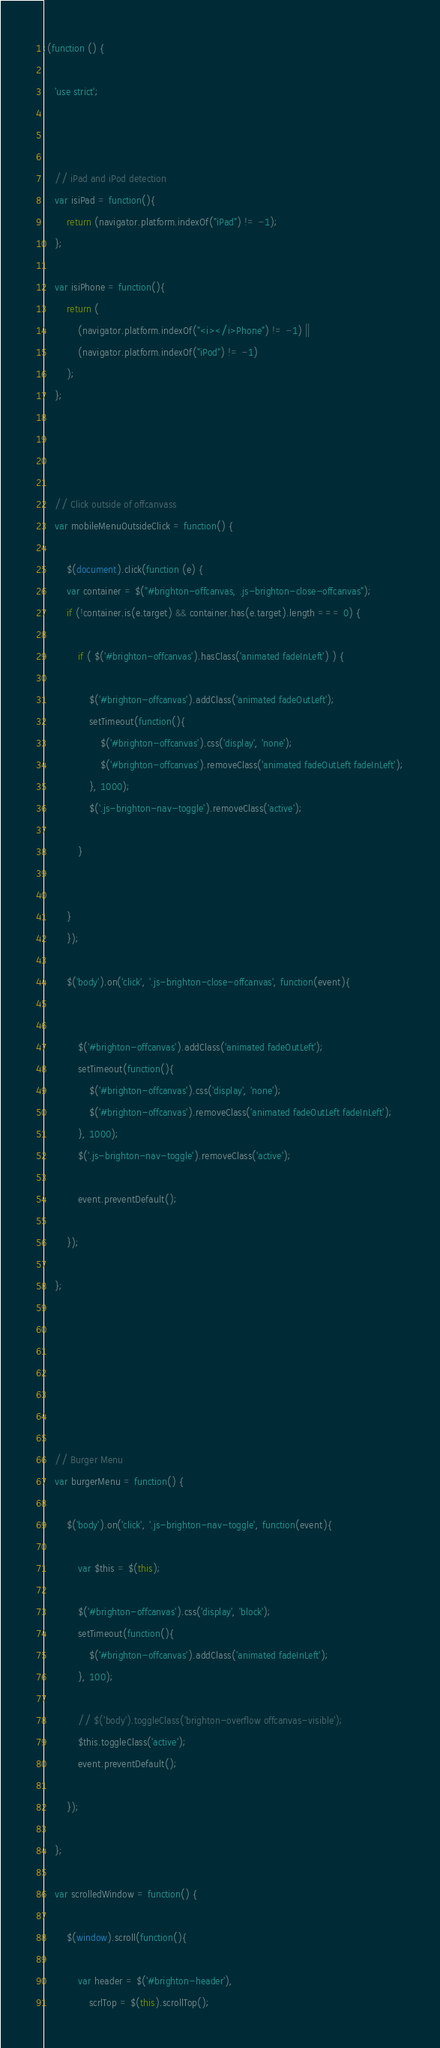<code> <loc_0><loc_0><loc_500><loc_500><_JavaScript_>;(function () {

	'use strict';



	// iPad and iPod detection
	var isiPad = function(){
		return (navigator.platform.indexOf("iPad") != -1);
	};

	var isiPhone = function(){
	    return (
			(navigator.platform.indexOf("<i></i>Phone") != -1) ||
			(navigator.platform.indexOf("iPod") != -1)
	    );
	};




	// Click outside of offcanvass
	var mobileMenuOutsideClick = function() {

		$(document).click(function (e) {
	    var container = $("#brighton-offcanvas, .js-brighton-close-offcanvas");
	    if (!container.is(e.target) && container.has(e.target).length === 0) {

	    	if ( $('#brighton-offcanvas').hasClass('animated fadeInLeft') ) {

    			$('#brighton-offcanvas').addClass('animated fadeOutLeft');
				setTimeout(function(){
					$('#brighton-offcanvas').css('display', 'none');
					$('#brighton-offcanvas').removeClass('animated fadeOutLeft fadeInLeft');
				}, 1000);
				$('.js-brighton-nav-toggle').removeClass('active');

	    	}


	    }
		});

		$('body').on('click', '.js-brighton-close-offcanvas', function(event){


	  		$('#brighton-offcanvas').addClass('animated fadeOutLeft');
			setTimeout(function(){
				$('#brighton-offcanvas').css('display', 'none');
				$('#brighton-offcanvas').removeClass('animated fadeOutLeft fadeInLeft');
			}, 1000);
			$('.js-brighton-nav-toggle').removeClass('active');

	    	event.preventDefault();

		});

	};







	// Burger Menu
	var burgerMenu = function() {

		$('body').on('click', '.js-brighton-nav-toggle', function(event){

			var $this = $(this);

			$('#brighton-offcanvas').css('display', 'block');
			setTimeout(function(){
				$('#brighton-offcanvas').addClass('animated fadeInLeft');
			}, 100);

			// $('body').toggleClass('brighton-overflow offcanvas-visible');
			$this.toggleClass('active');
			event.preventDefault();

		});

	};

	var scrolledWindow = function() {

		$(window).scroll(function(){

			var header = $('#brighton-header'),
				scrlTop = $(this).scrollTop();

</code> 